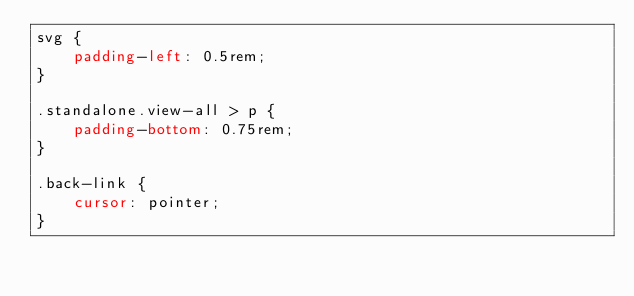<code> <loc_0><loc_0><loc_500><loc_500><_CSS_>svg {
    padding-left: 0.5rem;
}

.standalone.view-all > p {
    padding-bottom: 0.75rem;
}

.back-link {
    cursor: pointer;
}
</code> 